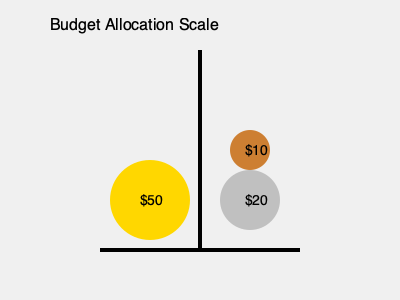As a financial advisor, you're helping a client balance their budget allocation. The scale represents different expense categories, with coins symbolizing budget amounts. The left side has a $50 coin, while the right side has a $20 coin and a $10 coin. What's the minimum amount (in dollars) that needs to be added to the right side to balance the scale, assuming all coins are of equal density? To solve this problem, we need to follow these steps:

1. Calculate the total value on the left side of the scale:
   Left side = $50

2. Calculate the total value on the right side of the scale:
   Right side = $20 + $10 = $30

3. Find the difference between the two sides:
   Difference = Left side - Right side
   Difference = $50 - $30 = $20

4. The minimum amount to be added to the right side is the difference:
   Amount to add = $20

Therefore, adding a $20 coin to the right side would balance the scale in terms of monetary value.

However, we need to consider the spatial aspect of the problem. The coins are of different sizes, which implies they represent different weights despite having equal density. To balance the scale physically, we need to account for the volume of the coins.

5. Assuming the volume is proportional to the coin's value:
   - $50 coin has a radius of 40 units
   - $20 coin has a radius of 30 units
   - $10 coin has a radius of 20 units

6. Calculate the volume (proportional to $\pi r^2$) for each side:
   Left side volume ∝ $50^2 = 2500$
   Right side volume ∝ $20^2 + 10^2 = 400 + 100 = 500$

7. Find the missing volume on the right side:
   Missing volume ∝ $2500 - 500 = 2000$

8. Determine the coin value that corresponds to this volume:
   $\sqrt{2000} \approx 44.72$

The closest standard coin value to 44.72 that would balance the scale both monetarily and spatially is $45.
Answer: $45 